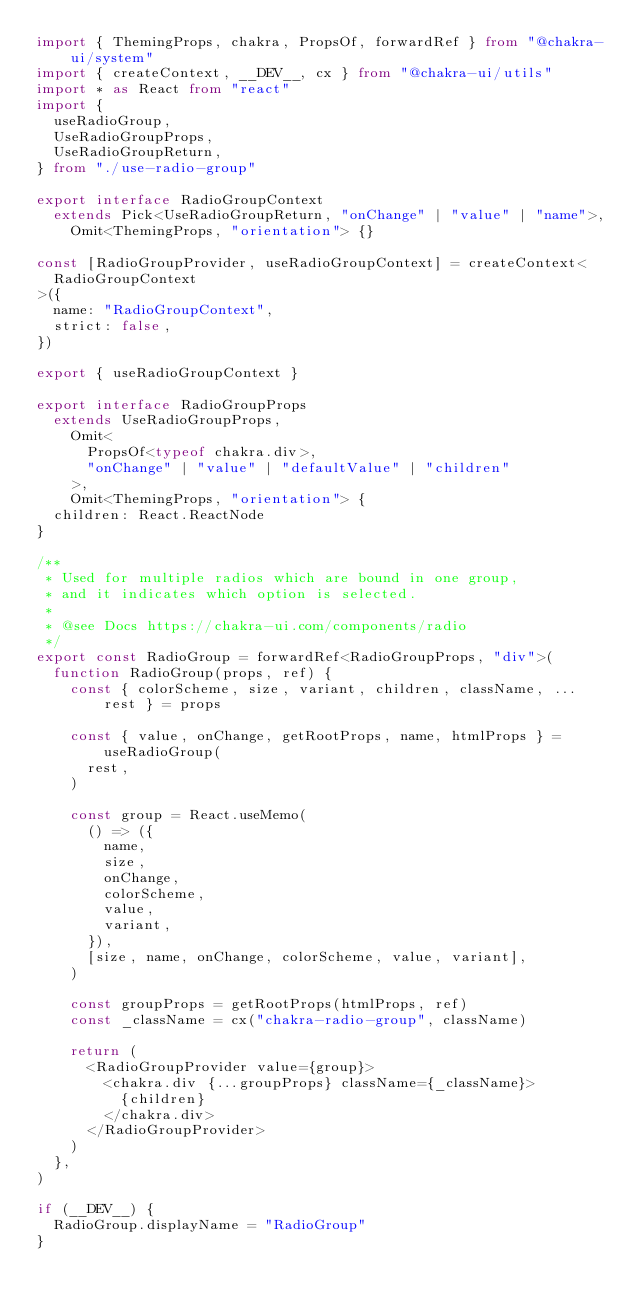<code> <loc_0><loc_0><loc_500><loc_500><_TypeScript_>import { ThemingProps, chakra, PropsOf, forwardRef } from "@chakra-ui/system"
import { createContext, __DEV__, cx } from "@chakra-ui/utils"
import * as React from "react"
import {
  useRadioGroup,
  UseRadioGroupProps,
  UseRadioGroupReturn,
} from "./use-radio-group"

export interface RadioGroupContext
  extends Pick<UseRadioGroupReturn, "onChange" | "value" | "name">,
    Omit<ThemingProps, "orientation"> {}

const [RadioGroupProvider, useRadioGroupContext] = createContext<
  RadioGroupContext
>({
  name: "RadioGroupContext",
  strict: false,
})

export { useRadioGroupContext }

export interface RadioGroupProps
  extends UseRadioGroupProps,
    Omit<
      PropsOf<typeof chakra.div>,
      "onChange" | "value" | "defaultValue" | "children"
    >,
    Omit<ThemingProps, "orientation"> {
  children: React.ReactNode
}

/**
 * Used for multiple radios which are bound in one group,
 * and it indicates which option is selected.
 *
 * @see Docs https://chakra-ui.com/components/radio
 */
export const RadioGroup = forwardRef<RadioGroupProps, "div">(
  function RadioGroup(props, ref) {
    const { colorScheme, size, variant, children, className, ...rest } = props

    const { value, onChange, getRootProps, name, htmlProps } = useRadioGroup(
      rest,
    )

    const group = React.useMemo(
      () => ({
        name,
        size,
        onChange,
        colorScheme,
        value,
        variant,
      }),
      [size, name, onChange, colorScheme, value, variant],
    )

    const groupProps = getRootProps(htmlProps, ref)
    const _className = cx("chakra-radio-group", className)

    return (
      <RadioGroupProvider value={group}>
        <chakra.div {...groupProps} className={_className}>
          {children}
        </chakra.div>
      </RadioGroupProvider>
    )
  },
)

if (__DEV__) {
  RadioGroup.displayName = "RadioGroup"
}
</code> 